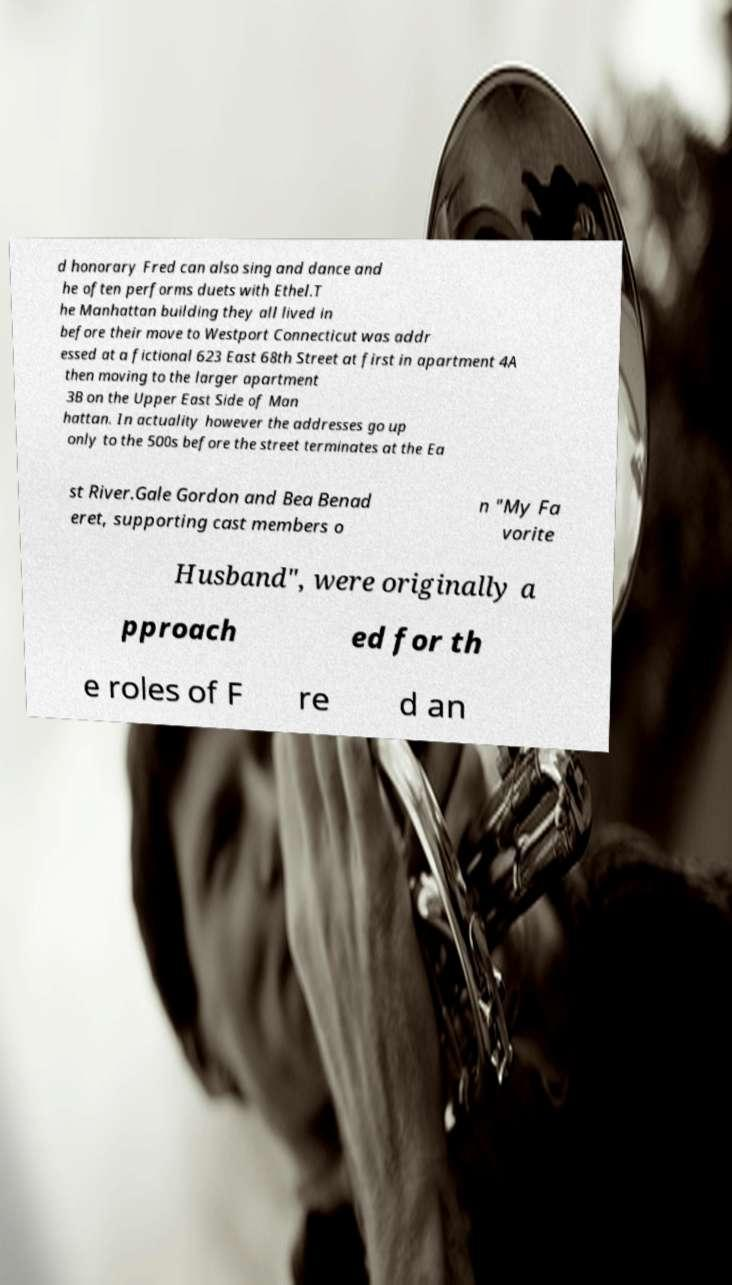For documentation purposes, I need the text within this image transcribed. Could you provide that? d honorary Fred can also sing and dance and he often performs duets with Ethel.T he Manhattan building they all lived in before their move to Westport Connecticut was addr essed at a fictional 623 East 68th Street at first in apartment 4A then moving to the larger apartment 3B on the Upper East Side of Man hattan. In actuality however the addresses go up only to the 500s before the street terminates at the Ea st River.Gale Gordon and Bea Benad eret, supporting cast members o n "My Fa vorite Husband", were originally a pproach ed for th e roles of F re d an 